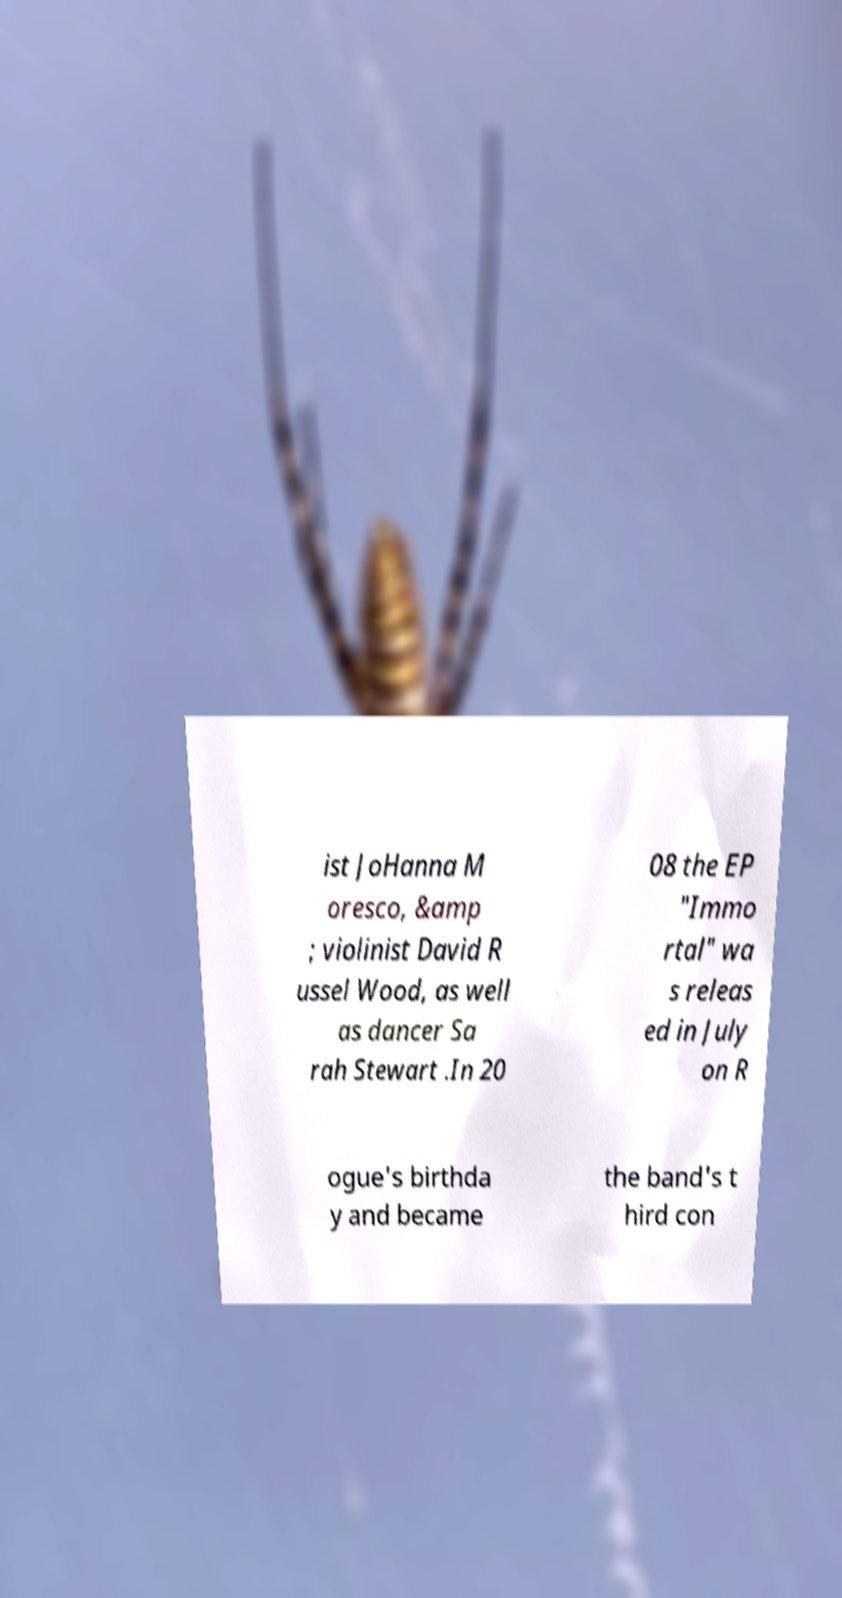Please read and relay the text visible in this image. What does it say? ist JoHanna M oresco, &amp ; violinist David R ussel Wood, as well as dancer Sa rah Stewart .In 20 08 the EP "Immo rtal" wa s releas ed in July on R ogue's birthda y and became the band's t hird con 